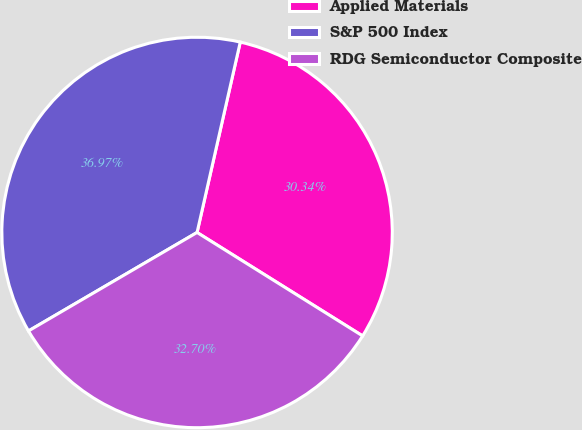Convert chart to OTSL. <chart><loc_0><loc_0><loc_500><loc_500><pie_chart><fcel>Applied Materials<fcel>S&P 500 Index<fcel>RDG Semiconductor Composite<nl><fcel>30.34%<fcel>36.97%<fcel>32.7%<nl></chart> 